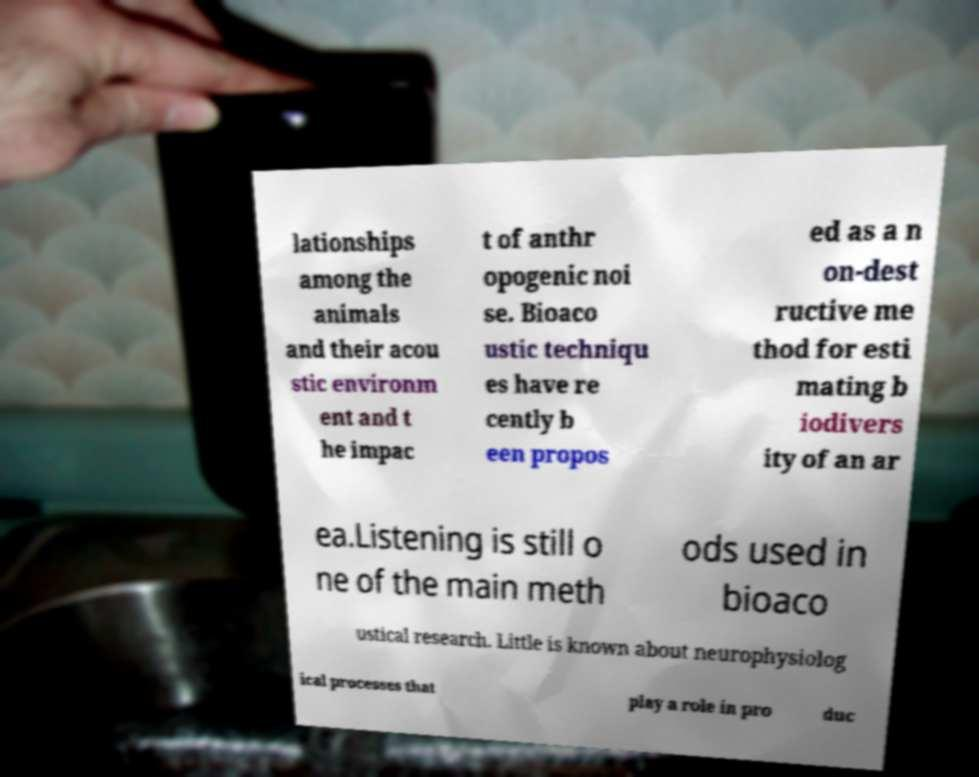Can you read and provide the text displayed in the image?This photo seems to have some interesting text. Can you extract and type it out for me? lationships among the animals and their acou stic environm ent and t he impac t of anthr opogenic noi se. Bioaco ustic techniqu es have re cently b een propos ed as a n on-dest ructive me thod for esti mating b iodivers ity of an ar ea.Listening is still o ne of the main meth ods used in bioaco ustical research. Little is known about neurophysiolog ical processes that play a role in pro duc 